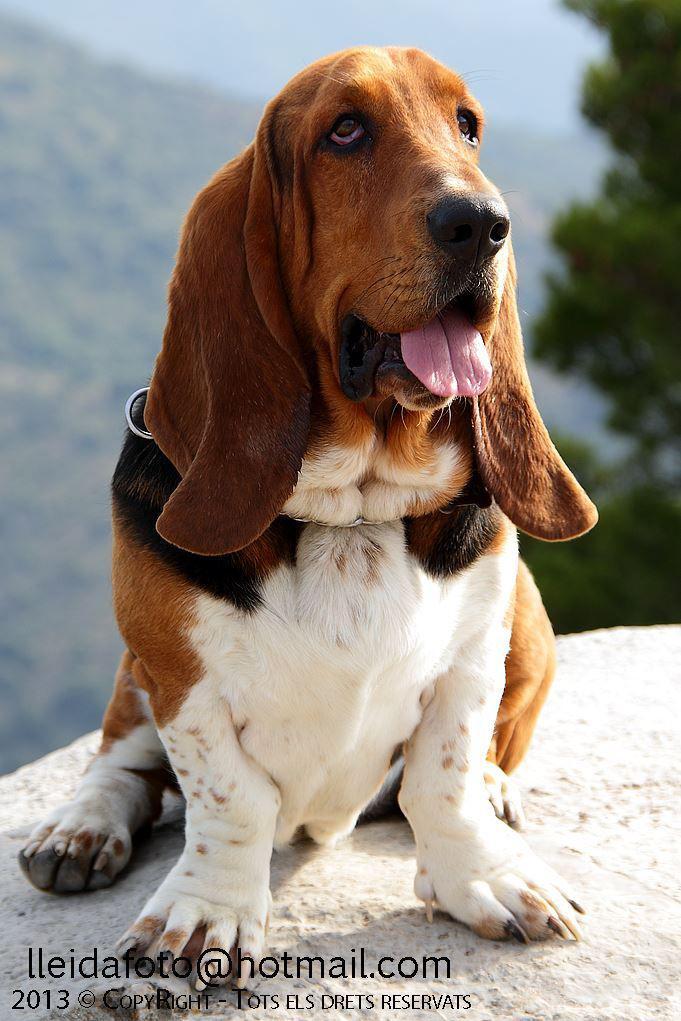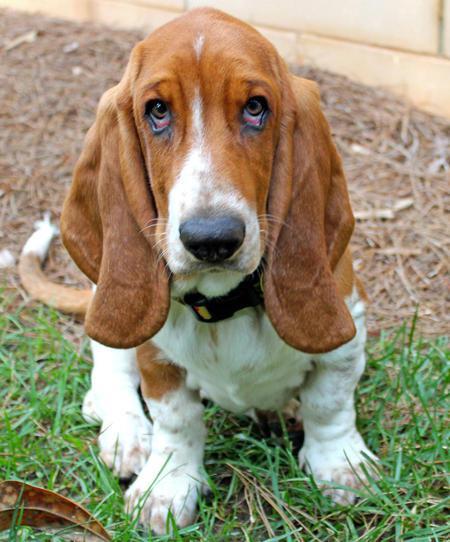The first image is the image on the left, the second image is the image on the right. Given the left and right images, does the statement "One of the images shows a dog on a bench." hold true? Answer yes or no. No. 